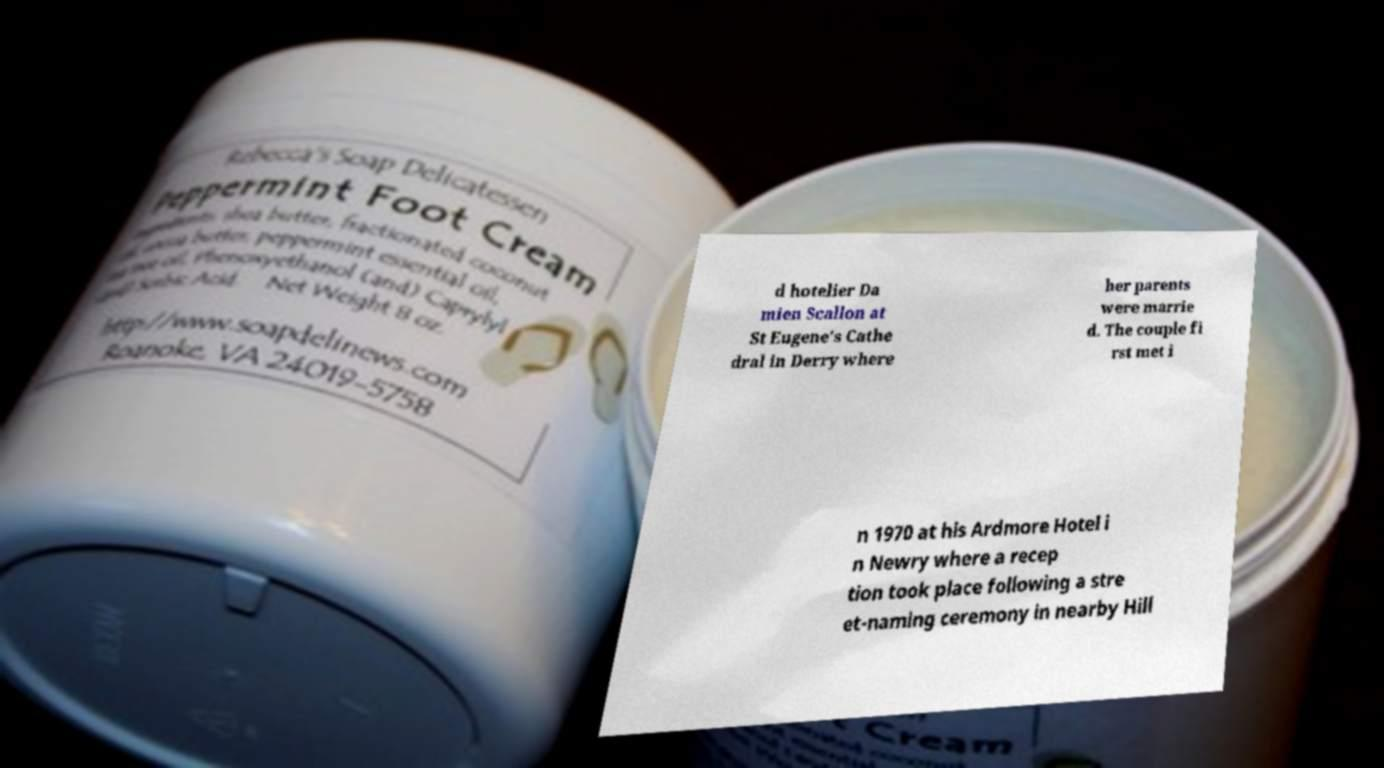Please identify and transcribe the text found in this image. d hotelier Da mien Scallon at St Eugene's Cathe dral in Derry where her parents were marrie d. The couple fi rst met i n 1970 at his Ardmore Hotel i n Newry where a recep tion took place following a stre et-naming ceremony in nearby Hill 